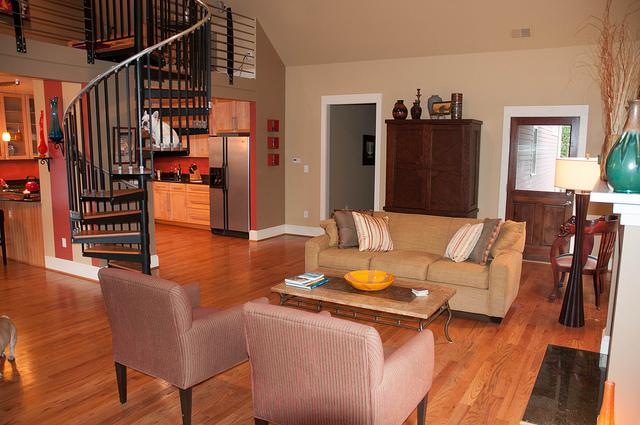What gives the square items on the couch their shape? stuffing 